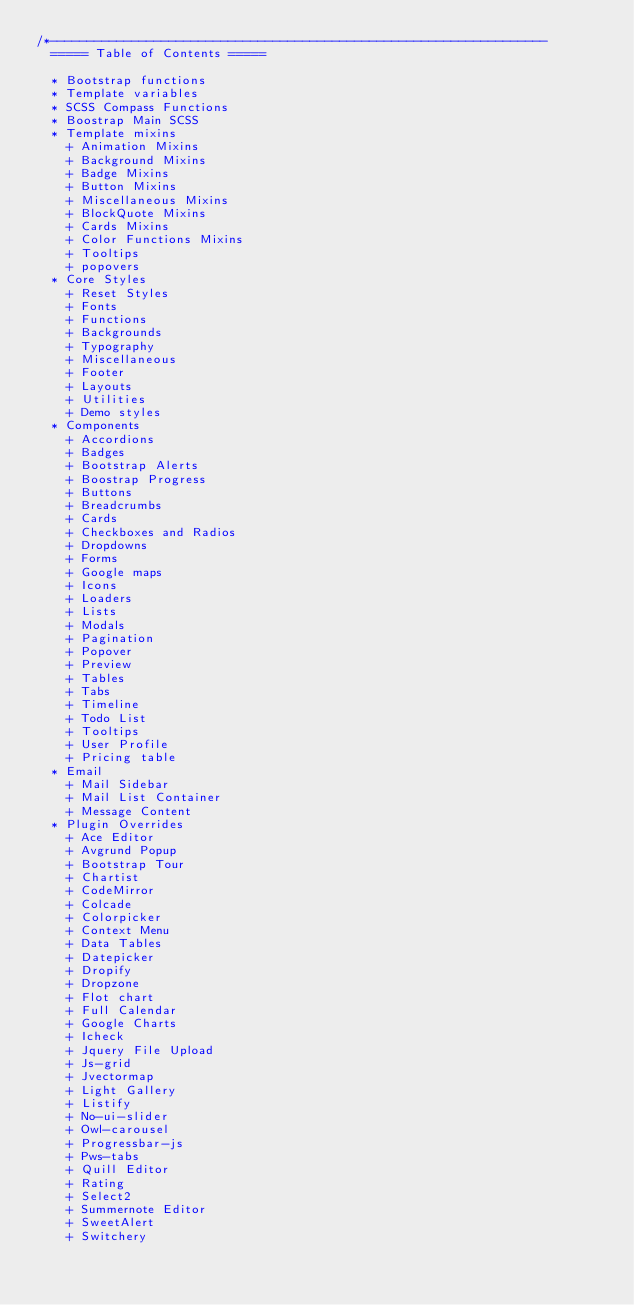<code> <loc_0><loc_0><loc_500><loc_500><_CSS_>/*-------------------------------------------------------------------
  ===== Table of Contents =====

  * Bootstrap functions
  * Template variables
  * SCSS Compass Functions
  * Boostrap Main SCSS
  * Template mixins
    + Animation Mixins
    + Background Mixins
    + Badge Mixins
    + Button Mixins
    + Miscellaneous Mixins
    + BlockQuote Mixins
    + Cards Mixins
    + Color Functions Mixins
    + Tooltips
    + popovers
  * Core Styles
    + Reset Styles
    + Fonts
    + Functions
    + Backgrounds
    + Typography
    + Miscellaneous
    + Footer
    + Layouts
    + Utilities
    + Demo styles
  * Components
    + Accordions
    + Badges
    + Bootstrap Alerts
    + Boostrap Progress
    + Buttons
    + Breadcrumbs
    + Cards
    + Checkboxes and Radios
    + Dropdowns
    + Forms
    + Google maps
    + Icons
    + Loaders
    + Lists
    + Modals
    + Pagination
    + Popover
    + Preview
    + Tables
    + Tabs
    + Timeline
    + Todo List
    + Tooltips
    + User Profile
    + Pricing table
  * Email
    + Mail Sidebar
    + Mail List Container
    + Message Content
  * Plugin Overrides
    + Ace Editor
    + Avgrund Popup
    + Bootstrap Tour
    + Chartist
    + CodeMirror
    + Colcade
    + Colorpicker
    + Context Menu
    + Data Tables
    + Datepicker
    + Dropify
    + Dropzone
    + Flot chart
    + Full Calendar
    + Google Charts
    + Icheck
    + Jquery File Upload
    + Js-grid
    + Jvectormap
    + Light Gallery
    + Listify
    + No-ui-slider
    + Owl-carousel
    + Progressbar-js
    + Pws-tabs
    + Quill Editor
    + Rating
    + Select2
    + Summernote Editor
    + SweetAlert
    + Switchery</code> 